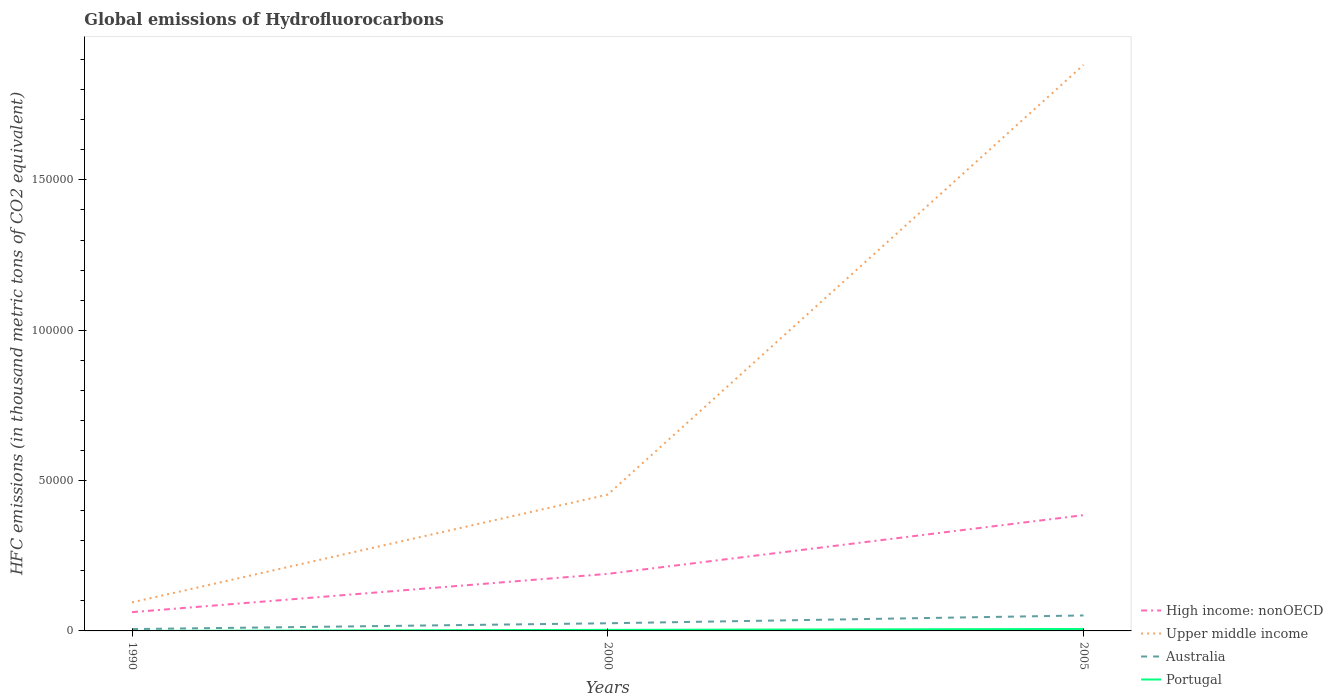How many different coloured lines are there?
Your answer should be very brief. 4. Does the line corresponding to High income: nonOECD intersect with the line corresponding to Upper middle income?
Provide a short and direct response. No. Across all years, what is the maximum global emissions of Hydrofluorocarbons in Australia?
Make the answer very short. 612.5. In which year was the global emissions of Hydrofluorocarbons in Australia maximum?
Offer a very short reply. 1990. What is the total global emissions of Hydrofluorocarbons in High income: nonOECD in the graph?
Your answer should be compact. -1.95e+04. What is the difference between the highest and the second highest global emissions of Hydrofluorocarbons in Australia?
Offer a terse response. 4533.1. What is the difference between the highest and the lowest global emissions of Hydrofluorocarbons in Portugal?
Your response must be concise. 2. Is the global emissions of Hydrofluorocarbons in Portugal strictly greater than the global emissions of Hydrofluorocarbons in Australia over the years?
Keep it short and to the point. Yes. How many lines are there?
Ensure brevity in your answer.  4. Does the graph contain any zero values?
Make the answer very short. No. Does the graph contain grids?
Ensure brevity in your answer.  No. Where does the legend appear in the graph?
Offer a terse response. Bottom right. What is the title of the graph?
Keep it short and to the point. Global emissions of Hydrofluorocarbons. What is the label or title of the Y-axis?
Offer a very short reply. HFC emissions (in thousand metric tons of CO2 equivalent). What is the HFC emissions (in thousand metric tons of CO2 equivalent) of High income: nonOECD in 1990?
Provide a short and direct response. 6246.3. What is the HFC emissions (in thousand metric tons of CO2 equivalent) in Upper middle income in 1990?
Make the answer very short. 9496.9. What is the HFC emissions (in thousand metric tons of CO2 equivalent) of Australia in 1990?
Ensure brevity in your answer.  612.5. What is the HFC emissions (in thousand metric tons of CO2 equivalent) in High income: nonOECD in 2000?
Give a very brief answer. 1.90e+04. What is the HFC emissions (in thousand metric tons of CO2 equivalent) of Upper middle income in 2000?
Your answer should be very brief. 4.53e+04. What is the HFC emissions (in thousand metric tons of CO2 equivalent) in Australia in 2000?
Offer a very short reply. 2545.7. What is the HFC emissions (in thousand metric tons of CO2 equivalent) in Portugal in 2000?
Offer a very short reply. 352.7. What is the HFC emissions (in thousand metric tons of CO2 equivalent) in High income: nonOECD in 2005?
Offer a terse response. 3.85e+04. What is the HFC emissions (in thousand metric tons of CO2 equivalent) of Upper middle income in 2005?
Offer a very short reply. 1.88e+05. What is the HFC emissions (in thousand metric tons of CO2 equivalent) of Australia in 2005?
Give a very brief answer. 5145.6. What is the HFC emissions (in thousand metric tons of CO2 equivalent) in Portugal in 2005?
Provide a short and direct response. 647.7. Across all years, what is the maximum HFC emissions (in thousand metric tons of CO2 equivalent) in High income: nonOECD?
Make the answer very short. 3.85e+04. Across all years, what is the maximum HFC emissions (in thousand metric tons of CO2 equivalent) of Upper middle income?
Your response must be concise. 1.88e+05. Across all years, what is the maximum HFC emissions (in thousand metric tons of CO2 equivalent) of Australia?
Your response must be concise. 5145.6. Across all years, what is the maximum HFC emissions (in thousand metric tons of CO2 equivalent) in Portugal?
Your response must be concise. 647.7. Across all years, what is the minimum HFC emissions (in thousand metric tons of CO2 equivalent) in High income: nonOECD?
Your answer should be very brief. 6246.3. Across all years, what is the minimum HFC emissions (in thousand metric tons of CO2 equivalent) of Upper middle income?
Provide a succinct answer. 9496.9. Across all years, what is the minimum HFC emissions (in thousand metric tons of CO2 equivalent) of Australia?
Provide a short and direct response. 612.5. What is the total HFC emissions (in thousand metric tons of CO2 equivalent) of High income: nonOECD in the graph?
Keep it short and to the point. 6.37e+04. What is the total HFC emissions (in thousand metric tons of CO2 equivalent) of Upper middle income in the graph?
Provide a short and direct response. 2.43e+05. What is the total HFC emissions (in thousand metric tons of CO2 equivalent) of Australia in the graph?
Your answer should be compact. 8303.8. What is the total HFC emissions (in thousand metric tons of CO2 equivalent) of Portugal in the graph?
Your answer should be compact. 1000.6. What is the difference between the HFC emissions (in thousand metric tons of CO2 equivalent) in High income: nonOECD in 1990 and that in 2000?
Make the answer very short. -1.27e+04. What is the difference between the HFC emissions (in thousand metric tons of CO2 equivalent) of Upper middle income in 1990 and that in 2000?
Your answer should be compact. -3.58e+04. What is the difference between the HFC emissions (in thousand metric tons of CO2 equivalent) of Australia in 1990 and that in 2000?
Your answer should be very brief. -1933.2. What is the difference between the HFC emissions (in thousand metric tons of CO2 equivalent) in Portugal in 1990 and that in 2000?
Give a very brief answer. -352.5. What is the difference between the HFC emissions (in thousand metric tons of CO2 equivalent) of High income: nonOECD in 1990 and that in 2005?
Make the answer very short. -3.23e+04. What is the difference between the HFC emissions (in thousand metric tons of CO2 equivalent) of Upper middle income in 1990 and that in 2005?
Give a very brief answer. -1.79e+05. What is the difference between the HFC emissions (in thousand metric tons of CO2 equivalent) in Australia in 1990 and that in 2005?
Give a very brief answer. -4533.1. What is the difference between the HFC emissions (in thousand metric tons of CO2 equivalent) of Portugal in 1990 and that in 2005?
Your response must be concise. -647.5. What is the difference between the HFC emissions (in thousand metric tons of CO2 equivalent) in High income: nonOECD in 2000 and that in 2005?
Offer a very short reply. -1.95e+04. What is the difference between the HFC emissions (in thousand metric tons of CO2 equivalent) of Upper middle income in 2000 and that in 2005?
Your response must be concise. -1.43e+05. What is the difference between the HFC emissions (in thousand metric tons of CO2 equivalent) in Australia in 2000 and that in 2005?
Keep it short and to the point. -2599.9. What is the difference between the HFC emissions (in thousand metric tons of CO2 equivalent) of Portugal in 2000 and that in 2005?
Give a very brief answer. -295. What is the difference between the HFC emissions (in thousand metric tons of CO2 equivalent) of High income: nonOECD in 1990 and the HFC emissions (in thousand metric tons of CO2 equivalent) of Upper middle income in 2000?
Your answer should be very brief. -3.91e+04. What is the difference between the HFC emissions (in thousand metric tons of CO2 equivalent) of High income: nonOECD in 1990 and the HFC emissions (in thousand metric tons of CO2 equivalent) of Australia in 2000?
Provide a short and direct response. 3700.6. What is the difference between the HFC emissions (in thousand metric tons of CO2 equivalent) in High income: nonOECD in 1990 and the HFC emissions (in thousand metric tons of CO2 equivalent) in Portugal in 2000?
Your answer should be compact. 5893.6. What is the difference between the HFC emissions (in thousand metric tons of CO2 equivalent) in Upper middle income in 1990 and the HFC emissions (in thousand metric tons of CO2 equivalent) in Australia in 2000?
Give a very brief answer. 6951.2. What is the difference between the HFC emissions (in thousand metric tons of CO2 equivalent) of Upper middle income in 1990 and the HFC emissions (in thousand metric tons of CO2 equivalent) of Portugal in 2000?
Ensure brevity in your answer.  9144.2. What is the difference between the HFC emissions (in thousand metric tons of CO2 equivalent) in Australia in 1990 and the HFC emissions (in thousand metric tons of CO2 equivalent) in Portugal in 2000?
Offer a terse response. 259.8. What is the difference between the HFC emissions (in thousand metric tons of CO2 equivalent) in High income: nonOECD in 1990 and the HFC emissions (in thousand metric tons of CO2 equivalent) in Upper middle income in 2005?
Keep it short and to the point. -1.82e+05. What is the difference between the HFC emissions (in thousand metric tons of CO2 equivalent) in High income: nonOECD in 1990 and the HFC emissions (in thousand metric tons of CO2 equivalent) in Australia in 2005?
Your answer should be compact. 1100.7. What is the difference between the HFC emissions (in thousand metric tons of CO2 equivalent) of High income: nonOECD in 1990 and the HFC emissions (in thousand metric tons of CO2 equivalent) of Portugal in 2005?
Ensure brevity in your answer.  5598.6. What is the difference between the HFC emissions (in thousand metric tons of CO2 equivalent) in Upper middle income in 1990 and the HFC emissions (in thousand metric tons of CO2 equivalent) in Australia in 2005?
Your answer should be compact. 4351.3. What is the difference between the HFC emissions (in thousand metric tons of CO2 equivalent) of Upper middle income in 1990 and the HFC emissions (in thousand metric tons of CO2 equivalent) of Portugal in 2005?
Make the answer very short. 8849.2. What is the difference between the HFC emissions (in thousand metric tons of CO2 equivalent) of Australia in 1990 and the HFC emissions (in thousand metric tons of CO2 equivalent) of Portugal in 2005?
Offer a terse response. -35.2. What is the difference between the HFC emissions (in thousand metric tons of CO2 equivalent) of High income: nonOECD in 2000 and the HFC emissions (in thousand metric tons of CO2 equivalent) of Upper middle income in 2005?
Give a very brief answer. -1.69e+05. What is the difference between the HFC emissions (in thousand metric tons of CO2 equivalent) in High income: nonOECD in 2000 and the HFC emissions (in thousand metric tons of CO2 equivalent) in Australia in 2005?
Keep it short and to the point. 1.38e+04. What is the difference between the HFC emissions (in thousand metric tons of CO2 equivalent) in High income: nonOECD in 2000 and the HFC emissions (in thousand metric tons of CO2 equivalent) in Portugal in 2005?
Your response must be concise. 1.83e+04. What is the difference between the HFC emissions (in thousand metric tons of CO2 equivalent) of Upper middle income in 2000 and the HFC emissions (in thousand metric tons of CO2 equivalent) of Australia in 2005?
Provide a short and direct response. 4.02e+04. What is the difference between the HFC emissions (in thousand metric tons of CO2 equivalent) of Upper middle income in 2000 and the HFC emissions (in thousand metric tons of CO2 equivalent) of Portugal in 2005?
Offer a terse response. 4.47e+04. What is the difference between the HFC emissions (in thousand metric tons of CO2 equivalent) in Australia in 2000 and the HFC emissions (in thousand metric tons of CO2 equivalent) in Portugal in 2005?
Make the answer very short. 1898. What is the average HFC emissions (in thousand metric tons of CO2 equivalent) of High income: nonOECD per year?
Your answer should be compact. 2.12e+04. What is the average HFC emissions (in thousand metric tons of CO2 equivalent) of Upper middle income per year?
Offer a terse response. 8.10e+04. What is the average HFC emissions (in thousand metric tons of CO2 equivalent) in Australia per year?
Offer a terse response. 2767.93. What is the average HFC emissions (in thousand metric tons of CO2 equivalent) in Portugal per year?
Keep it short and to the point. 333.53. In the year 1990, what is the difference between the HFC emissions (in thousand metric tons of CO2 equivalent) of High income: nonOECD and HFC emissions (in thousand metric tons of CO2 equivalent) of Upper middle income?
Your answer should be compact. -3250.6. In the year 1990, what is the difference between the HFC emissions (in thousand metric tons of CO2 equivalent) of High income: nonOECD and HFC emissions (in thousand metric tons of CO2 equivalent) of Australia?
Your answer should be very brief. 5633.8. In the year 1990, what is the difference between the HFC emissions (in thousand metric tons of CO2 equivalent) in High income: nonOECD and HFC emissions (in thousand metric tons of CO2 equivalent) in Portugal?
Your answer should be very brief. 6246.1. In the year 1990, what is the difference between the HFC emissions (in thousand metric tons of CO2 equivalent) in Upper middle income and HFC emissions (in thousand metric tons of CO2 equivalent) in Australia?
Your answer should be very brief. 8884.4. In the year 1990, what is the difference between the HFC emissions (in thousand metric tons of CO2 equivalent) in Upper middle income and HFC emissions (in thousand metric tons of CO2 equivalent) in Portugal?
Offer a very short reply. 9496.7. In the year 1990, what is the difference between the HFC emissions (in thousand metric tons of CO2 equivalent) in Australia and HFC emissions (in thousand metric tons of CO2 equivalent) in Portugal?
Your answer should be compact. 612.3. In the year 2000, what is the difference between the HFC emissions (in thousand metric tons of CO2 equivalent) in High income: nonOECD and HFC emissions (in thousand metric tons of CO2 equivalent) in Upper middle income?
Provide a succinct answer. -2.64e+04. In the year 2000, what is the difference between the HFC emissions (in thousand metric tons of CO2 equivalent) in High income: nonOECD and HFC emissions (in thousand metric tons of CO2 equivalent) in Australia?
Offer a terse response. 1.64e+04. In the year 2000, what is the difference between the HFC emissions (in thousand metric tons of CO2 equivalent) in High income: nonOECD and HFC emissions (in thousand metric tons of CO2 equivalent) in Portugal?
Offer a very short reply. 1.86e+04. In the year 2000, what is the difference between the HFC emissions (in thousand metric tons of CO2 equivalent) in Upper middle income and HFC emissions (in thousand metric tons of CO2 equivalent) in Australia?
Offer a very short reply. 4.28e+04. In the year 2000, what is the difference between the HFC emissions (in thousand metric tons of CO2 equivalent) of Upper middle income and HFC emissions (in thousand metric tons of CO2 equivalent) of Portugal?
Give a very brief answer. 4.50e+04. In the year 2000, what is the difference between the HFC emissions (in thousand metric tons of CO2 equivalent) in Australia and HFC emissions (in thousand metric tons of CO2 equivalent) in Portugal?
Make the answer very short. 2193. In the year 2005, what is the difference between the HFC emissions (in thousand metric tons of CO2 equivalent) of High income: nonOECD and HFC emissions (in thousand metric tons of CO2 equivalent) of Upper middle income?
Ensure brevity in your answer.  -1.50e+05. In the year 2005, what is the difference between the HFC emissions (in thousand metric tons of CO2 equivalent) of High income: nonOECD and HFC emissions (in thousand metric tons of CO2 equivalent) of Australia?
Provide a succinct answer. 3.34e+04. In the year 2005, what is the difference between the HFC emissions (in thousand metric tons of CO2 equivalent) in High income: nonOECD and HFC emissions (in thousand metric tons of CO2 equivalent) in Portugal?
Keep it short and to the point. 3.79e+04. In the year 2005, what is the difference between the HFC emissions (in thousand metric tons of CO2 equivalent) of Upper middle income and HFC emissions (in thousand metric tons of CO2 equivalent) of Australia?
Give a very brief answer. 1.83e+05. In the year 2005, what is the difference between the HFC emissions (in thousand metric tons of CO2 equivalent) of Upper middle income and HFC emissions (in thousand metric tons of CO2 equivalent) of Portugal?
Give a very brief answer. 1.88e+05. In the year 2005, what is the difference between the HFC emissions (in thousand metric tons of CO2 equivalent) of Australia and HFC emissions (in thousand metric tons of CO2 equivalent) of Portugal?
Keep it short and to the point. 4497.9. What is the ratio of the HFC emissions (in thousand metric tons of CO2 equivalent) of High income: nonOECD in 1990 to that in 2000?
Keep it short and to the point. 0.33. What is the ratio of the HFC emissions (in thousand metric tons of CO2 equivalent) in Upper middle income in 1990 to that in 2000?
Your answer should be very brief. 0.21. What is the ratio of the HFC emissions (in thousand metric tons of CO2 equivalent) in Australia in 1990 to that in 2000?
Your answer should be very brief. 0.24. What is the ratio of the HFC emissions (in thousand metric tons of CO2 equivalent) in Portugal in 1990 to that in 2000?
Keep it short and to the point. 0. What is the ratio of the HFC emissions (in thousand metric tons of CO2 equivalent) in High income: nonOECD in 1990 to that in 2005?
Make the answer very short. 0.16. What is the ratio of the HFC emissions (in thousand metric tons of CO2 equivalent) in Upper middle income in 1990 to that in 2005?
Provide a short and direct response. 0.05. What is the ratio of the HFC emissions (in thousand metric tons of CO2 equivalent) of Australia in 1990 to that in 2005?
Provide a succinct answer. 0.12. What is the ratio of the HFC emissions (in thousand metric tons of CO2 equivalent) of High income: nonOECD in 2000 to that in 2005?
Provide a short and direct response. 0.49. What is the ratio of the HFC emissions (in thousand metric tons of CO2 equivalent) of Upper middle income in 2000 to that in 2005?
Your answer should be compact. 0.24. What is the ratio of the HFC emissions (in thousand metric tons of CO2 equivalent) in Australia in 2000 to that in 2005?
Give a very brief answer. 0.49. What is the ratio of the HFC emissions (in thousand metric tons of CO2 equivalent) of Portugal in 2000 to that in 2005?
Give a very brief answer. 0.54. What is the difference between the highest and the second highest HFC emissions (in thousand metric tons of CO2 equivalent) in High income: nonOECD?
Provide a succinct answer. 1.95e+04. What is the difference between the highest and the second highest HFC emissions (in thousand metric tons of CO2 equivalent) in Upper middle income?
Provide a short and direct response. 1.43e+05. What is the difference between the highest and the second highest HFC emissions (in thousand metric tons of CO2 equivalent) of Australia?
Provide a short and direct response. 2599.9. What is the difference between the highest and the second highest HFC emissions (in thousand metric tons of CO2 equivalent) in Portugal?
Offer a very short reply. 295. What is the difference between the highest and the lowest HFC emissions (in thousand metric tons of CO2 equivalent) of High income: nonOECD?
Your answer should be compact. 3.23e+04. What is the difference between the highest and the lowest HFC emissions (in thousand metric tons of CO2 equivalent) in Upper middle income?
Keep it short and to the point. 1.79e+05. What is the difference between the highest and the lowest HFC emissions (in thousand metric tons of CO2 equivalent) of Australia?
Your response must be concise. 4533.1. What is the difference between the highest and the lowest HFC emissions (in thousand metric tons of CO2 equivalent) of Portugal?
Offer a very short reply. 647.5. 